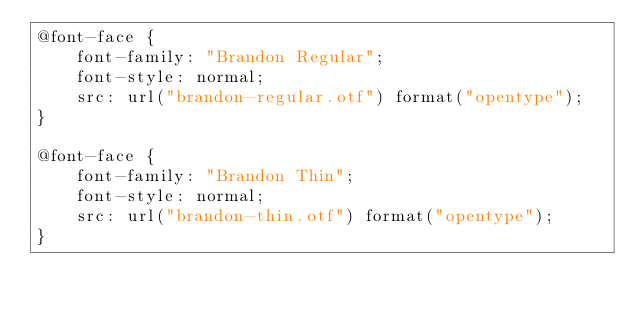<code> <loc_0><loc_0><loc_500><loc_500><_CSS_>@font-face {
    font-family: "Brandon Regular";
    font-style: normal;
    src: url("brandon-regular.otf") format("opentype");
}

@font-face {
    font-family: "Brandon Thin";
    font-style: normal;
    src: url("brandon-thin.otf") format("opentype");
}</code> 